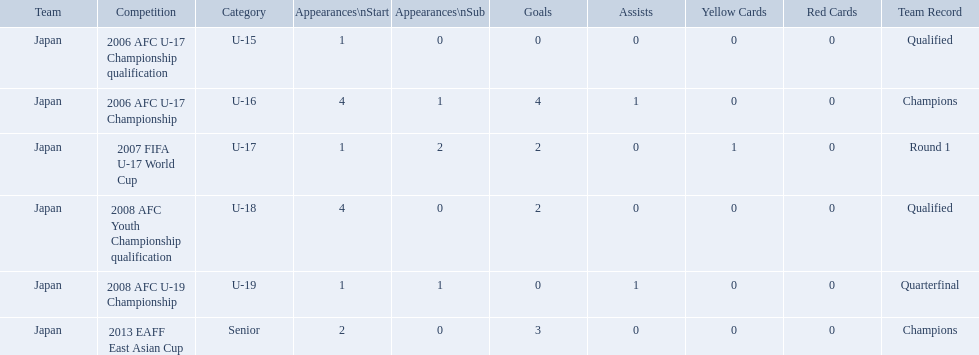What competitions did japan compete in with yoichiro kakitani? 2006 AFC U-17 Championship qualification, 2006 AFC U-17 Championship, 2007 FIFA U-17 World Cup, 2008 AFC Youth Championship qualification, 2008 AFC U-19 Championship, 2013 EAFF East Asian Cup. Of those competitions, which were held in 2007 and 2013? 2007 FIFA U-17 World Cup, 2013 EAFF East Asian Cup. Of the 2007 fifa u-17 world cup and the 2013 eaff east asian cup, which did japan have the most starting appearances? 2013 EAFF East Asian Cup. Which competitions had champions team records? 2006 AFC U-17 Championship, 2013 EAFF East Asian Cup. Of these competitions, which one was in the senior category? 2013 EAFF East Asian Cup. Which competitions has yoichiro kakitani participated in? 2006 AFC U-17 Championship qualification, 2006 AFC U-17 Championship, 2007 FIFA U-17 World Cup, 2008 AFC Youth Championship qualification, 2008 AFC U-19 Championship, 2013 EAFF East Asian Cup. How many times did he start during each competition? 1, 4, 1, 4, 1, 2. How many goals did he score during those? 0, 4, 2, 2, 0, 3. And during which competition did yoichiro achieve the most starts and goals? 2006 AFC U-17 Championship. 